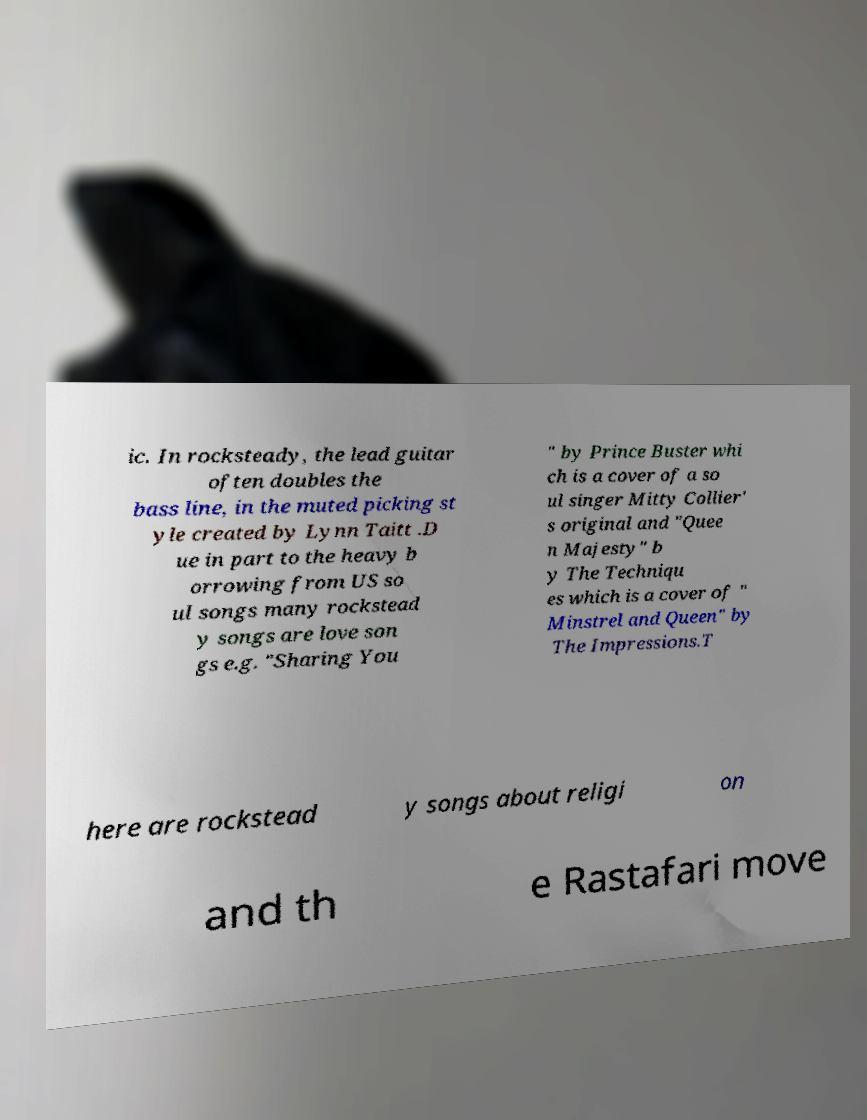Can you read and provide the text displayed in the image?This photo seems to have some interesting text. Can you extract and type it out for me? ic. In rocksteady, the lead guitar often doubles the bass line, in the muted picking st yle created by Lynn Taitt .D ue in part to the heavy b orrowing from US so ul songs many rockstead y songs are love son gs e.g. "Sharing You " by Prince Buster whi ch is a cover of a so ul singer Mitty Collier' s original and "Quee n Majesty" b y The Techniqu es which is a cover of " Minstrel and Queen" by The Impressions.T here are rockstead y songs about religi on and th e Rastafari move 